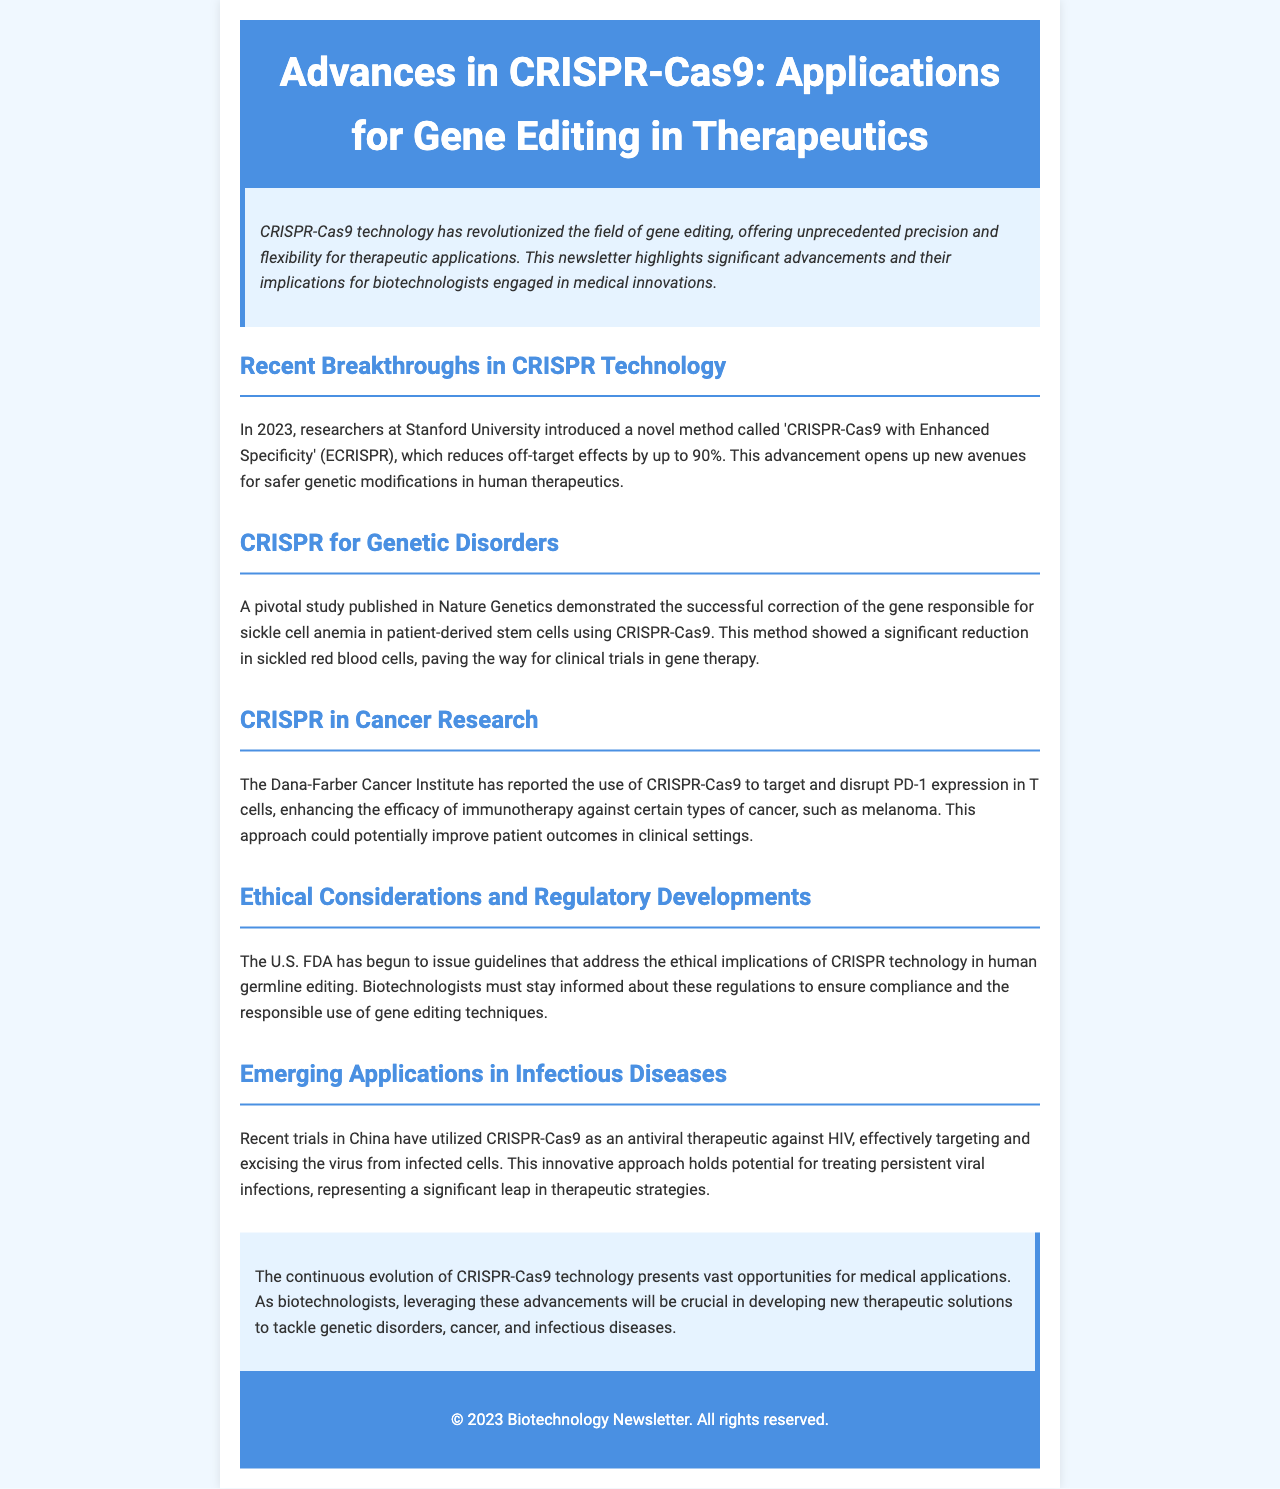What is the novel method introduced at Stanford University? The document mentions that in 2023, researchers at Stanford University introduced a method called 'CRISPR-Cas9 with Enhanced Specificity' (ECRISPR).
Answer: ECRISPR What gene disorder was targeted for correction using CRISPR-Cas9? The newsletter states that a pivotal study corrected the gene responsible for sickle cell anemia using CRISPR-Cas9.
Answer: Sickle cell anemia What institute reported the use of CRISPR in cancer research? According to the document, the Dana-Farber Cancer Institute reported the use of CRISPR-Cas9 to enhance the efficacy of immunotherapy.
Answer: Dana-Farber Cancer Institute By what percentage does ECRISPR reduce off-target effects? The newsletter claims that ECRISPR reduces off-target effects by up to 90%.
Answer: 90% What is the potential application of CRISPR-Cas9 demonstrated in recent trials in China? The document indicates that trials have utilized CRISPR-Cas9 as an antiviral therapeutic against HIV.
Answer: Antiviral therapeutic against HIV What important guidelines has the U.S. FDA begun to issue? The document states that the U.S. FDA has begun to issue guidelines addressing the ethical implications of CRISPR technology in human germline editing.
Answer: Ethical implications of CRISPR technology in human germline editing What year was the significant advancement in CRISPR technology reported? The newsletter notes that the significant advancements were reported in the year 2023.
Answer: 2023 What type of document is this? The structure and content indicate that this document is a newsletter highlighting advances in CRISPR-Cas9 technology.
Answer: Newsletter 